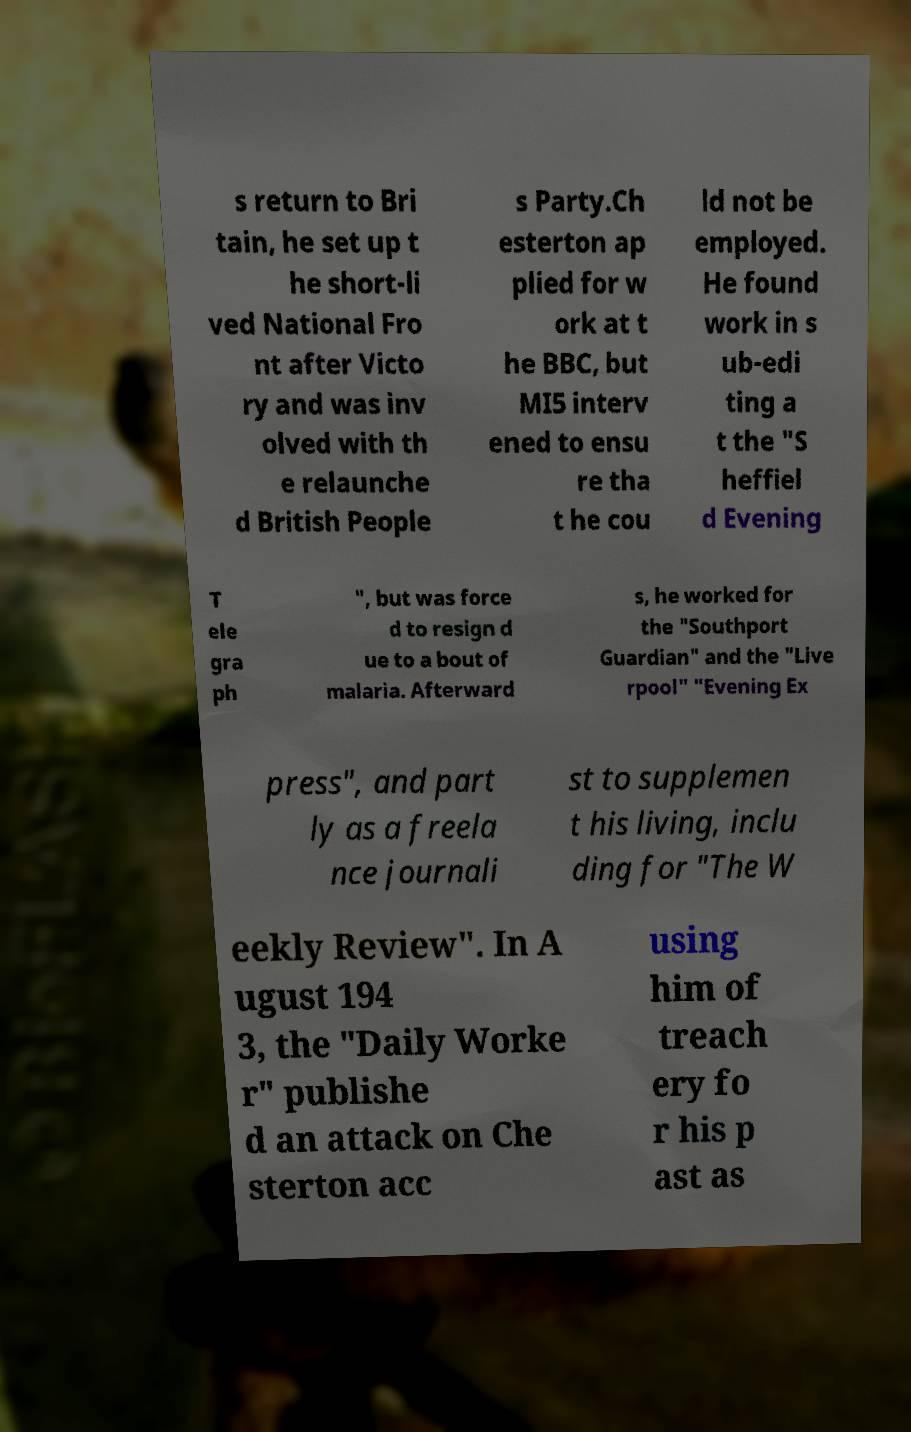I need the written content from this picture converted into text. Can you do that? s return to Bri tain, he set up t he short-li ved National Fro nt after Victo ry and was inv olved with th e relaunche d British People s Party.Ch esterton ap plied for w ork at t he BBC, but MI5 interv ened to ensu re tha t he cou ld not be employed. He found work in s ub-edi ting a t the "S heffiel d Evening T ele gra ph ", but was force d to resign d ue to a bout of malaria. Afterward s, he worked for the "Southport Guardian" and the "Live rpool" "Evening Ex press", and part ly as a freela nce journali st to supplemen t his living, inclu ding for "The W eekly Review". In A ugust 194 3, the "Daily Worke r" publishe d an attack on Che sterton acc using him of treach ery fo r his p ast as 